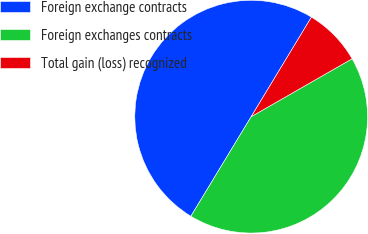Convert chart to OTSL. <chart><loc_0><loc_0><loc_500><loc_500><pie_chart><fcel>Foreign exchange contracts<fcel>Foreign exchanges contracts<fcel>Total gain (loss) recognized<nl><fcel>50.0%<fcel>41.96%<fcel>8.04%<nl></chart> 